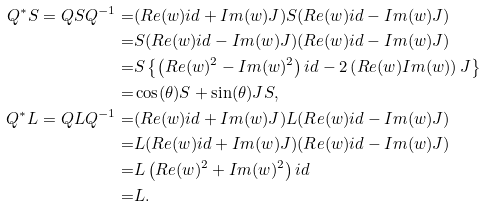<formula> <loc_0><loc_0><loc_500><loc_500>Q ^ { * } S = Q S Q ^ { - 1 } = & ( R e ( w ) i d + I m ( w ) J ) S ( R e ( w ) i d - I m ( w ) J ) \\ = & S ( R e ( w ) i d - I m ( w ) J ) ( R e ( w ) i d - I m ( w ) J ) \\ = & S \left \{ \left ( R e ( w ) ^ { 2 } - I m ( w ) ^ { 2 } \right ) i d - 2 \left ( R e ( w ) I m ( w ) \right ) J \right \} \\ = & \cos ( \theta ) S + \sin ( \theta ) J S , \\ Q ^ { * } L = Q L Q ^ { - 1 } = & ( R e ( w ) i d + I m ( w ) J ) L ( R e ( w ) i d - I m ( w ) J ) \\ = & L ( R e ( w ) i d + I m ( w ) J ) ( R e ( w ) i d - I m ( w ) J ) \\ = & L \left ( R e ( w ) ^ { 2 } + I m ( w ) ^ { 2 } \right ) i d \\ = & L .</formula> 